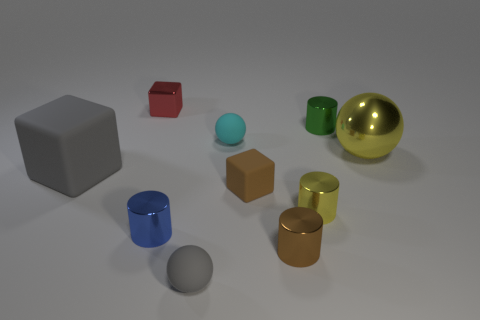Subtract all red cylinders. Subtract all red spheres. How many cylinders are left? 4 Subtract all spheres. How many objects are left? 7 Add 6 metal blocks. How many metal blocks exist? 7 Subtract 0 blue spheres. How many objects are left? 10 Subtract all cylinders. Subtract all big gray matte blocks. How many objects are left? 5 Add 7 big yellow balls. How many big yellow balls are left? 8 